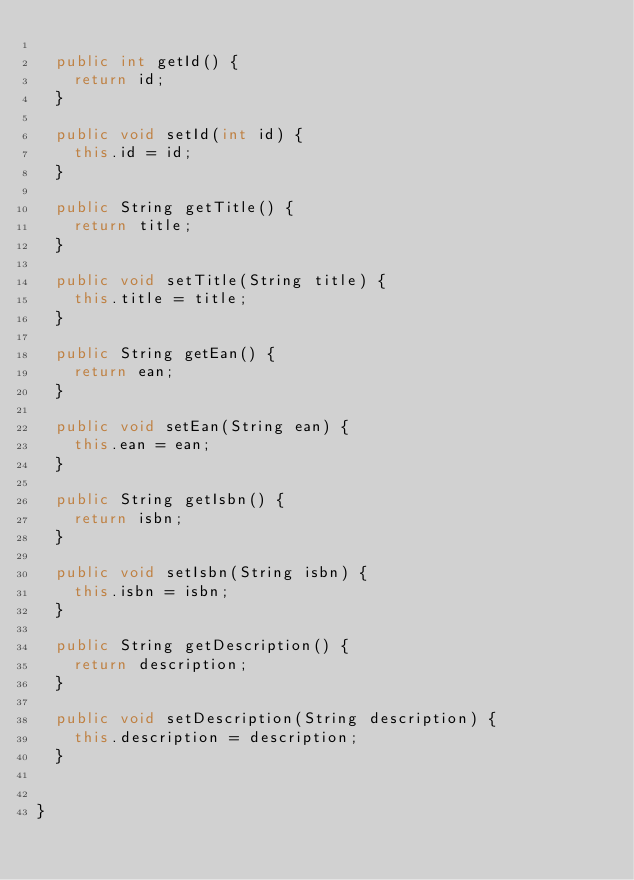<code> <loc_0><loc_0><loc_500><loc_500><_Java_>
	public int getId() {
		return id;
	}

	public void setId(int id) {
		this.id = id;
	}

	public String getTitle() {
		return title;
	}

	public void setTitle(String title) {
		this.title = title;
	}

	public String getEan() {
		return ean;
	}

	public void setEan(String ean) {
		this.ean = ean;
	}

	public String getIsbn() {
		return isbn;
	}

	public void setIsbn(String isbn) {
		this.isbn = isbn;
	}

	public String getDescription() {
		return description;
	}

	public void setDescription(String description) {
		this.description = description;
	}
	
	
}
</code> 